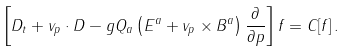Convert formula to latex. <formula><loc_0><loc_0><loc_500><loc_500>\left [ D _ { t } + { v } _ { p } \cdot { D } - g Q _ { a } \left ( { E } ^ { a } + { v } _ { p } \times { B } ^ { a } \right ) \frac { \partial } { \partial { p } } \right ] f = C [ f ] \, .</formula> 